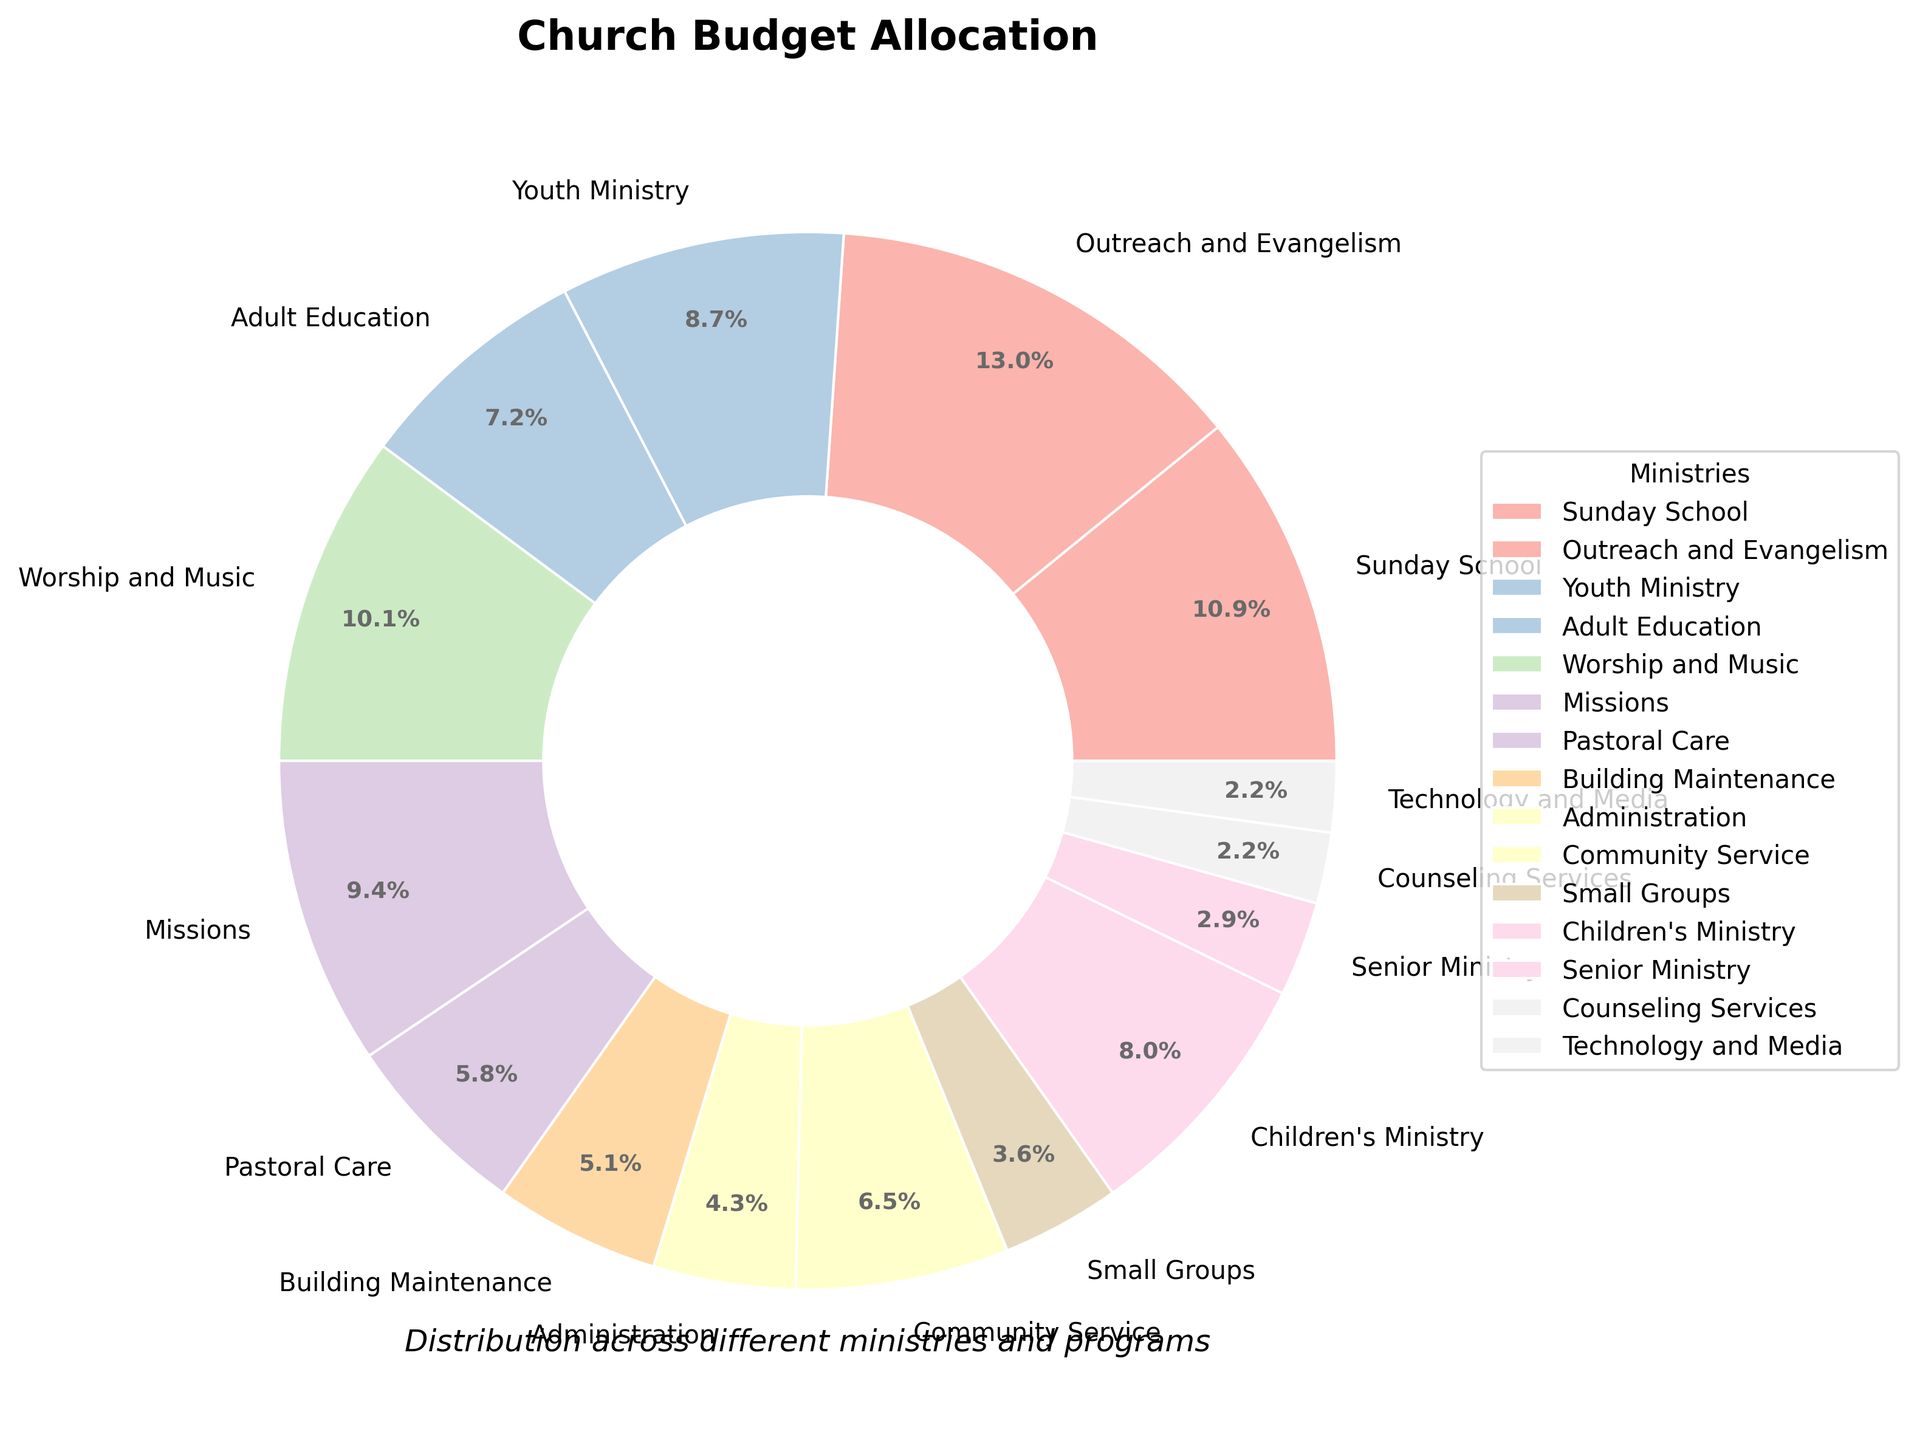what percentage of the budget is allocated to Sunday School and Youth Ministry combined? Sum the percentages allocated to Sunday School (15%) and Youth Ministry (12%). The combined percentage is 15 + 12 = 27%
Answer: 27% Which ministry has a greater budget allocation: Worship and Music or Missions? Check the percentages for both ministries. Worship and Music has 14% while Missions has 13%. Comparing the two, Worship and Music has a greater allocation.
Answer: Worship and Music What is the difference in budget allocation between Community Service and Building Maintenance? Subtract the allocation percentage of Building Maintenance (7%) from Community Service (9%). The difference is 9 - 7 = 2%
Answer: 2% Which ministry has the smallest budget allocation? Identify the ministry with the lowest percentage. Counseling Services and Technology and Media both have the smallest allocation of 3%.
Answer: Counseling Services and Technology and Media What is the visual representation (color) of Adult Education? Look at the pie chart segment labeled Adult Education and note its color. The color of Adult Education can be described visually (dependent on the color used, e.g., pastel blue, pink, etc.).
Answer: (Answer will vary based on actual rendering; describe the observed color) How much more budget percentage is allocated to Outreach and Evangelism compared to Administration? Subtract the allocation percentage for Administration (6%) from Outreach and Evangelism (18%). The difference is 18 - 6 = 12%
Answer: 12% Is the budget allocation for Children's Ministry higher or lower than Adult Education? Compare the percentages for both ministries. Children's Ministry has 11% while Adult Education has 10%. Children's Ministry has a higher allocation.
Answer: Higher What is the combined budget allocation for Community Service, Pastoral Care, and Small Groups? Sum the allocation percentages: Community Service (9%) + Pastoral Care (8%) + Small Groups (5%). The combined allocation is 9 + 8 + 5 = 22%
Answer: 22% What percentage of the budget is allocated to ministries with a percentage less than 10%? Identify the ministries with less than 10%: Adult Education (10%), Pastoral Care (8%), Administration (6%), Small Groups (5%), Senior Ministry (4%), Counseling Services (3%), Technology and Media (3%). Sum the percentages (10 + 8 + 6 + 5 + 4 + 3 + 3 = 39%).
Answer: 39% 